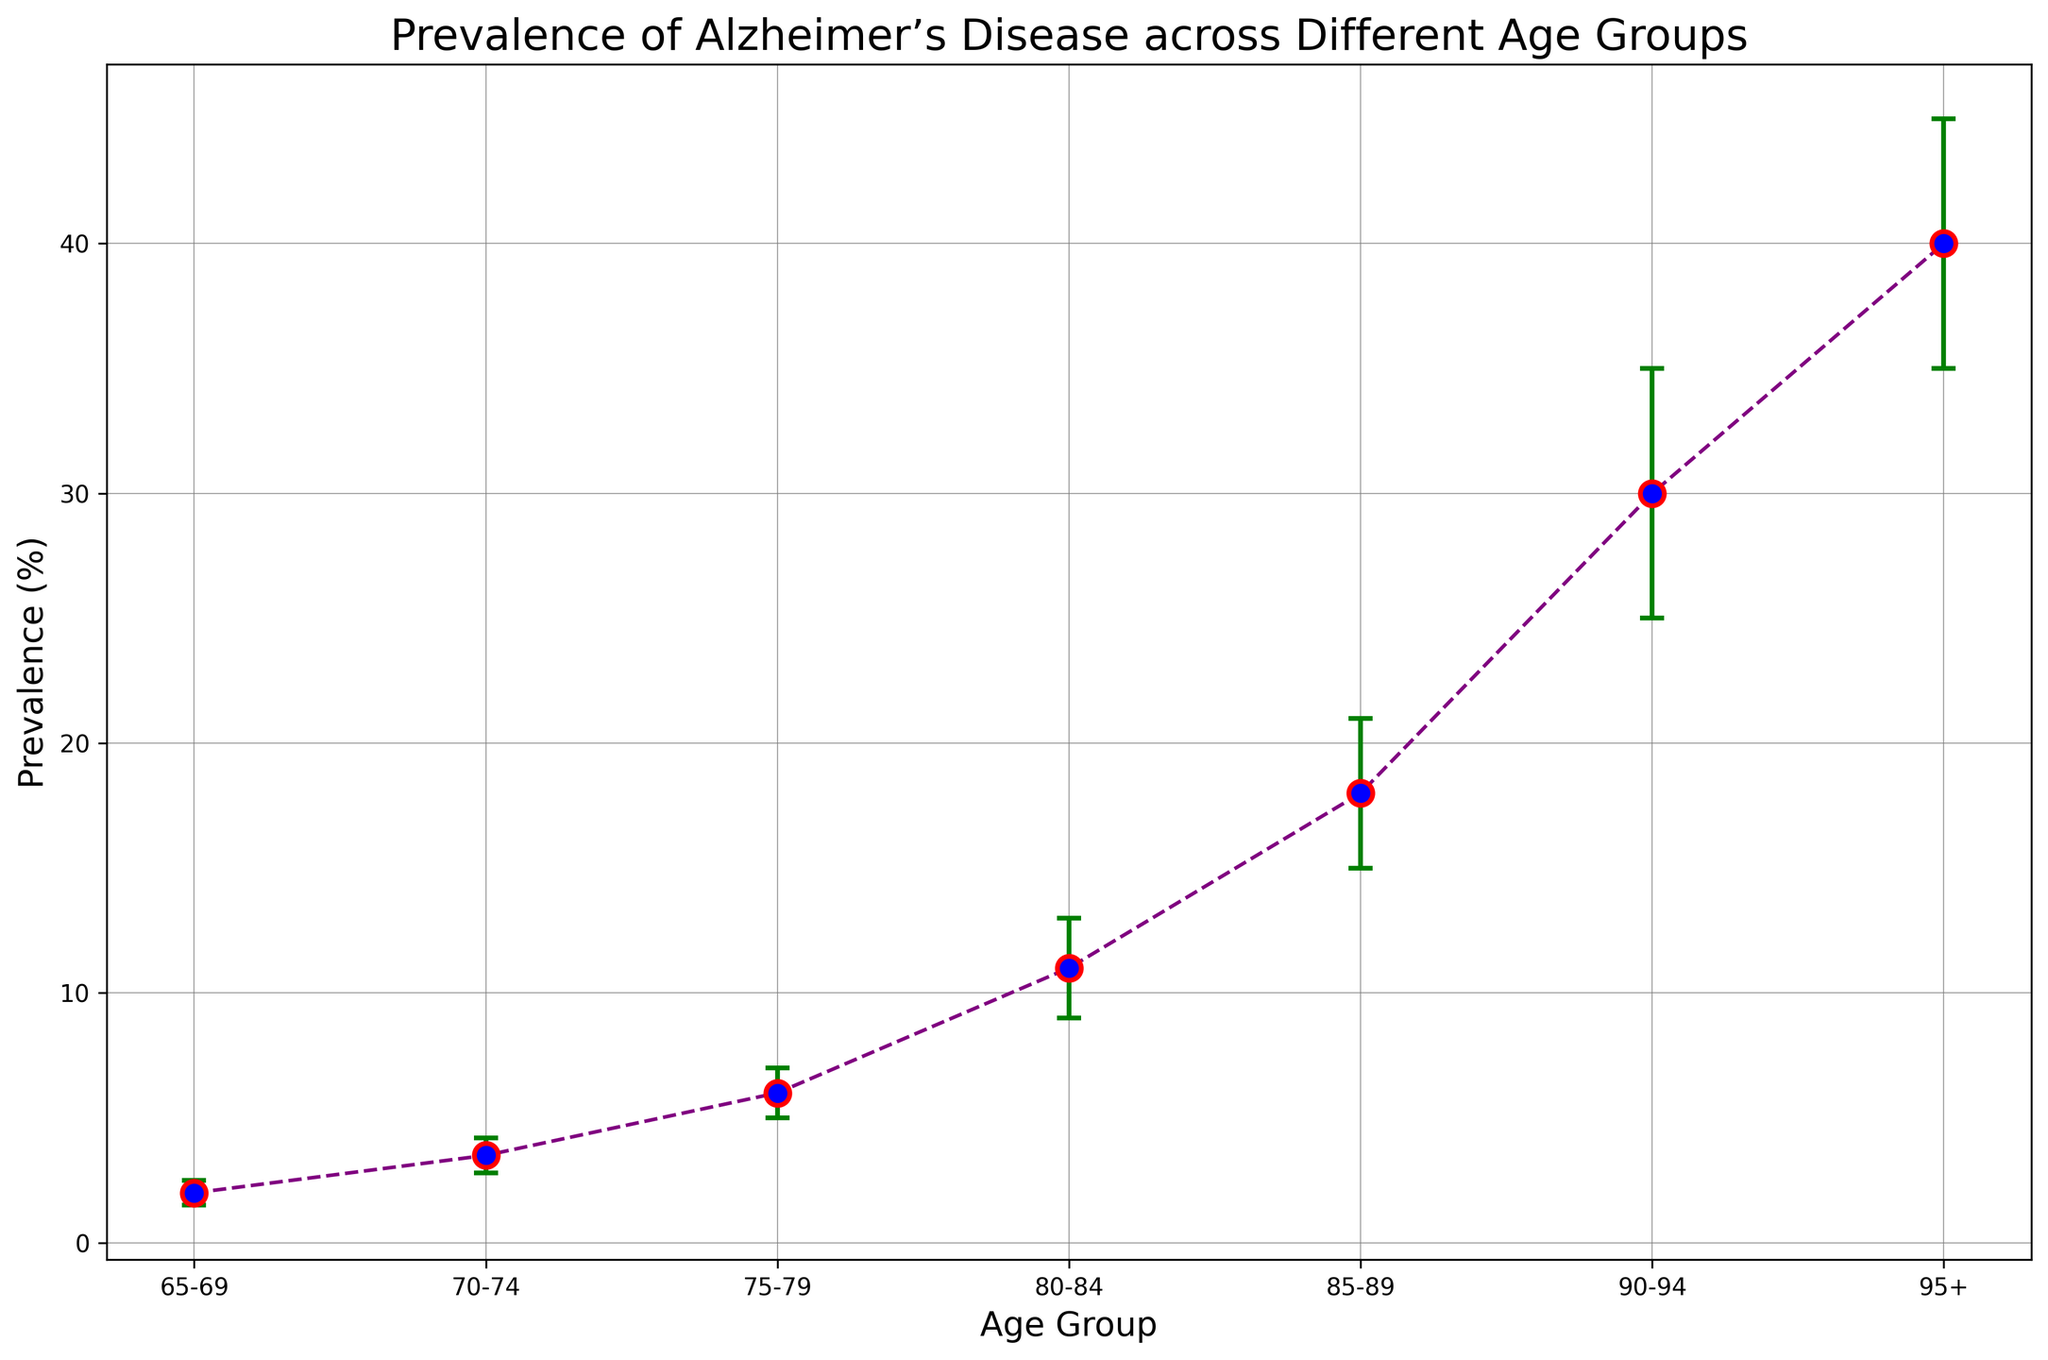What is the prevalence of Alzheimer's Disease in the 75-79 age group? The figure shows that for the 75-79 age group, the prevalence percentage is plotted, which is 6.0.
Answer: 6.0% What age group has the highest prevalence of Alzheimer’s Disease? By observing the plotted prevalence values, the age group 95+ has the highest prevalence percentage.
Answer: 95+ What is the range of the confidence interval for the 80-84 age group? The confidence interval for the 80-84 age group is provided as 9.0-13.0, giving a range from 9.0 to 13.0.
Answer: 9.0-13.0 How does the prevalence percent change from the 65-69 age group to the 70-74 age group? The prevalence for the 65-69 age group is 2.0%, and it increases to 3.5% in the 70-74 age group. The change is 3.5% - 2.0% = 1.5%.
Answer: 1.5% Which age group has the smallest confidence interval range, and what is that range? By comparing the ranges (difference between upper and lower bounds) for each group, the 70-74 age group has the smallest range, calculated as 4.2 - 2.8 = 1.4.
Answer: 1.4 Compare the prevalence of Alzheimer’s Disease in the 85-89 and 90-94 age groups. Which one is higher, and by how much? Prevalence for 85-89 is 18.0%, and for 90-94, it is 30.0%. The difference between them is 30.0% - 18.0% = 12.0%.
Answer: 12.0% For which age group is the prevalence least certain, according to the confidence interval? The 95+ age group has the widest confidence interval with a range of 10 (45.0 - 35.0 = 10.0).
Answer: 95+ Between which two consecutive age groups is the increase in prevalence the greatest? Calculating the increase between consecutive groups: 
65-69 to 70-74: 3.5 - 2.0 = 1.5,
70-74 to 75-79: 6.0 - 3.5 = 2.5,
75-79 to 80-84: 11.0 - 6.0 = 5.0,
80-84 to 85-89: 18.0 - 11.0 = 7.0,
85-89 to 90-94: 30.0 - 18.0 = 12.0,
90-94 to 95+: 40.0 - 30.0 = 10.0.
The greatest increase is from 85-89 to 90-94, which is 12.0.
Answer: 85-89 to 90-94 What is the average prevalence of Alzheimer's Disease among the age groups 70-74, 75-79, and 80-84? The prevalence percentages are 3.5, 6.0, and 11.0. The average is calculated as (3.5 + 6.0 + 11.0) / 3 = 6.83%.
Answer: 6.83% Based on the error bars, which age group has the smallest uncertainty relative to its prevalence? Relative uncertainty can be approximated by the width of the confidence interval divided by the prevalence. E.g., for 70-74, it's (4.2 - 2.8)/3.5 = 0.4. Repeating this:
65-69: (2.5 - 1.5)/2.0 = 0.5,
70-74: 0.4,
75-79: 1.0,
80-84: 0.364,
85-89: 0.333,
90-94: 0.333,
95+: 0.25.
The 95+ age group has the smallest relative uncertainty.
Answer: 95+ 